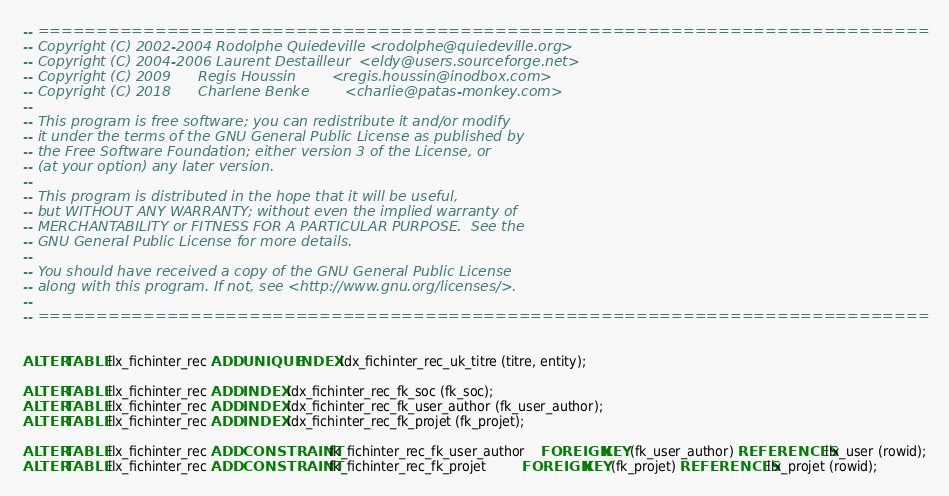<code> <loc_0><loc_0><loc_500><loc_500><_SQL_>-- ============================================================================
-- Copyright (C) 2002-2004 Rodolphe Quiedeville <rodolphe@quiedeville.org>
-- Copyright (C) 2004-2006 Laurent Destailleur  <eldy@users.sourceforge.net>
-- Copyright (C) 2009      Regis Houssin        <regis.houssin@inodbox.com>
-- Copyright (C) 2018      Charlene Benke        <charlie@patas-monkey.com>
--
-- This program is free software; you can redistribute it and/or modify
-- it under the terms of the GNU General Public License as published by
-- the Free Software Foundation; either version 3 of the License, or
-- (at your option) any later version.
--
-- This program is distributed in the hope that it will be useful,
-- but WITHOUT ANY WARRANTY; without even the implied warranty of
-- MERCHANTABILITY or FITNESS FOR A PARTICULAR PURPOSE.  See the
-- GNU General Public License for more details.
--
-- You should have received a copy of the GNU General Public License
-- along with this program. If not, see <http://www.gnu.org/licenses/>.
--
-- ============================================================================


ALTER TABLE llx_fichinter_rec ADD UNIQUE INDEX idx_fichinter_rec_uk_titre (titre, entity);

ALTER TABLE llx_fichinter_rec ADD INDEX idx_fichinter_rec_fk_soc (fk_soc);
ALTER TABLE llx_fichinter_rec ADD INDEX idx_fichinter_rec_fk_user_author (fk_user_author);
ALTER TABLE llx_fichinter_rec ADD INDEX idx_fichinter_rec_fk_projet (fk_projet);

ALTER TABLE llx_fichinter_rec ADD CONSTRAINT fk_fichinter_rec_fk_user_author    FOREIGN KEY (fk_user_author) REFERENCES llx_user (rowid);
ALTER TABLE llx_fichinter_rec ADD CONSTRAINT fk_fichinter_rec_fk_projet         FOREIGN KEY (fk_projet) REFERENCES llx_projet (rowid);
</code> 